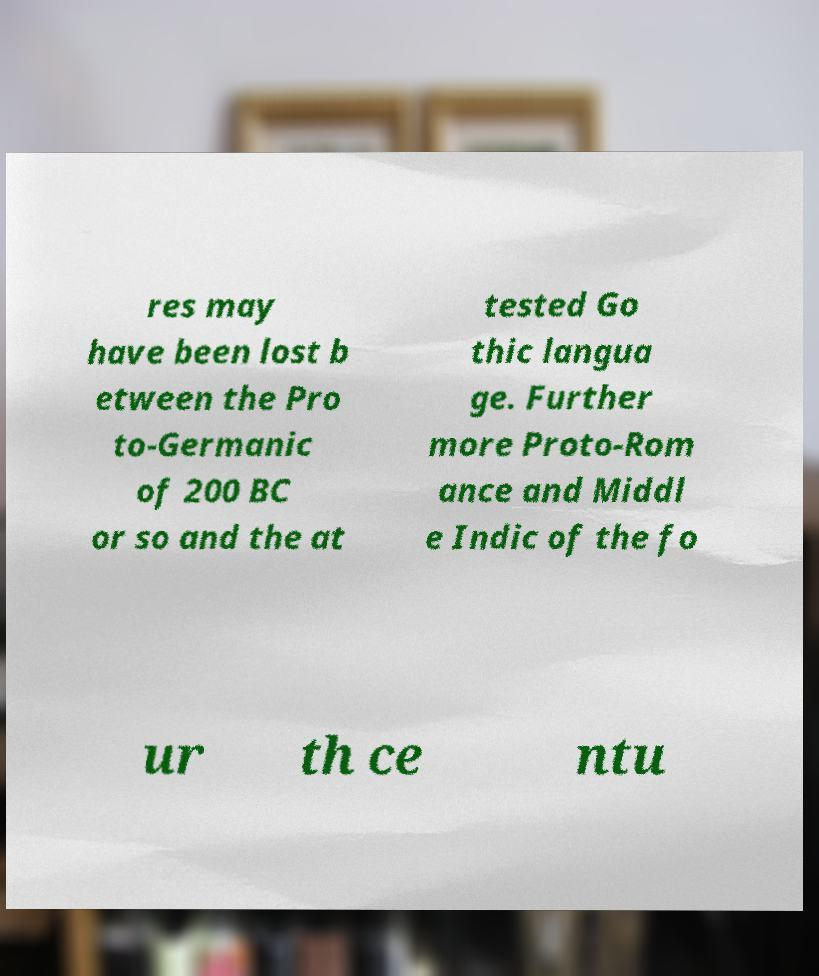For documentation purposes, I need the text within this image transcribed. Could you provide that? res may have been lost b etween the Pro to-Germanic of 200 BC or so and the at tested Go thic langua ge. Further more Proto-Rom ance and Middl e Indic of the fo ur th ce ntu 